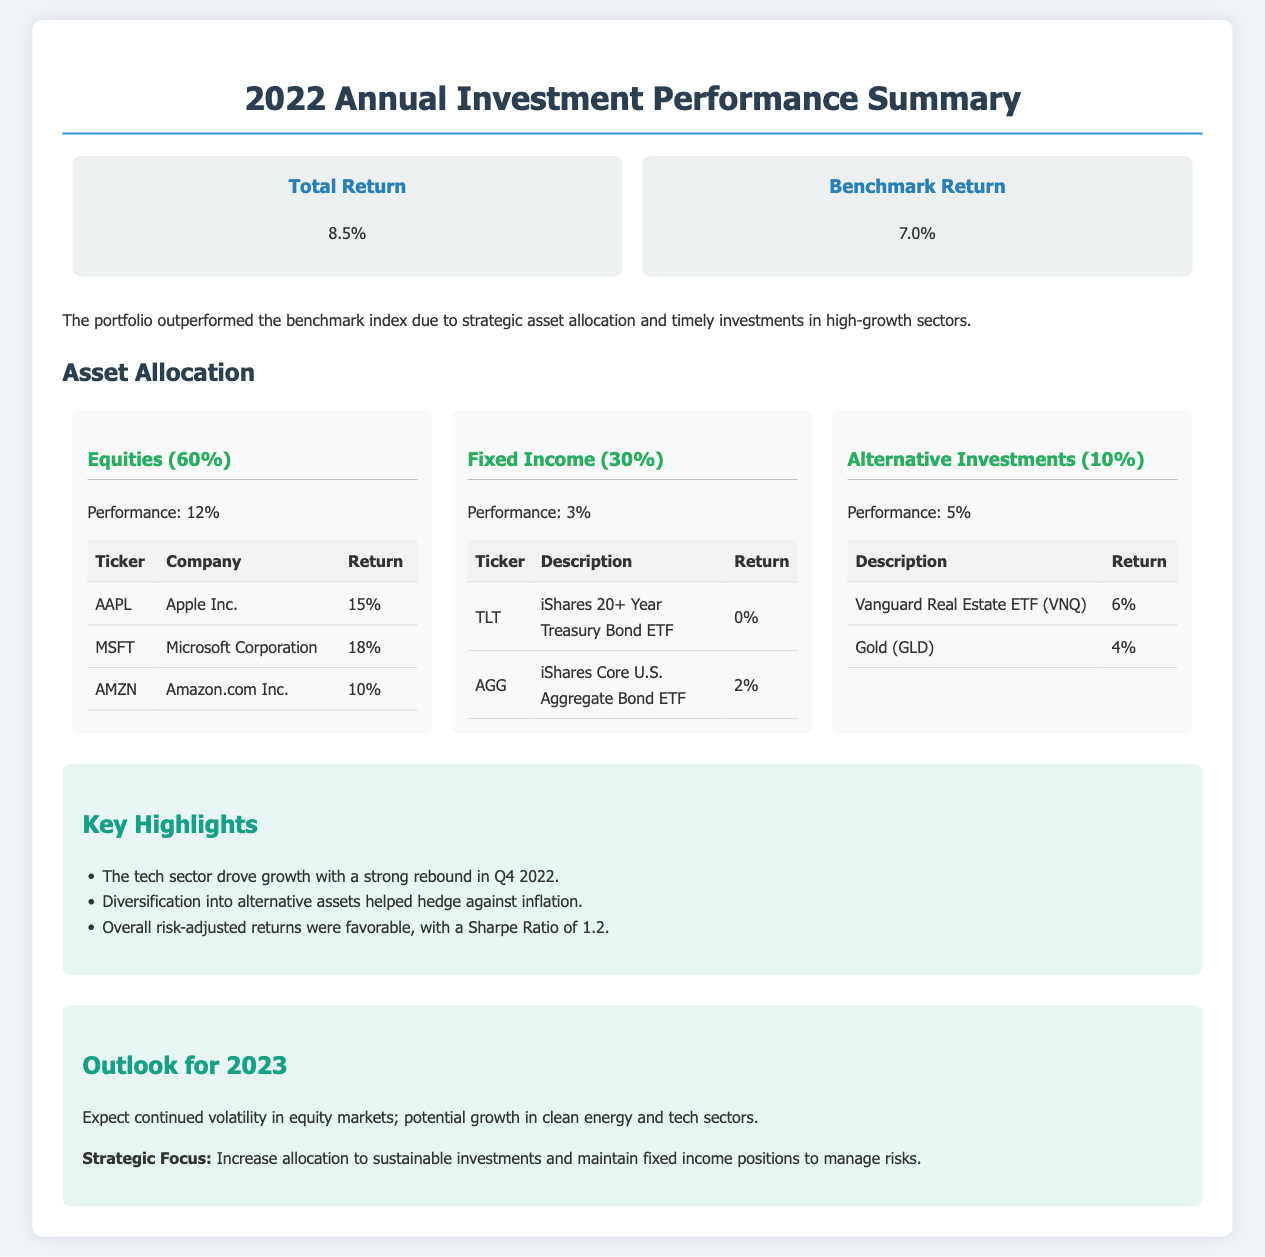What was the total return for 2022? The total return for 2022 is explicitly stated in the performance summary section of the document.
Answer: 8.5% What was the benchmark return for 2022? The benchmark return is compared to the total return in the performance summary section.
Answer: 7.0% What percentage of the portfolio is allocated to equities? The asset allocation section indicates the percentage allocated to equities.
Answer: 60% What was the performance of the fixed income category? The performance of the fixed income category is given in the asset allocation section under the corresponding category.
Answer: 3% Which company had the highest return among equities? The table listing equity returns shows which company performed best.
Answer: Microsoft Corporation What was the Sharpe Ratio mentioned in the report? The Sharpe Ratio is a performance metric mentioned in the key highlights section of the document.
Answer: 1.2 What is one of the strategic focuses for 2023? The outlook section specifies the strategic focus areas for the upcoming year.
Answer: Increase allocation to sustainable investments What sector drove growth in Q4 2022? The key highlights mention which sector significantly contributed to growth during the fourth quarter.
Answer: Tech sector What is the performance of the Alternative Investments category? The asset allocation section specifies the performance figure for alternative investments.
Answer: 5% 